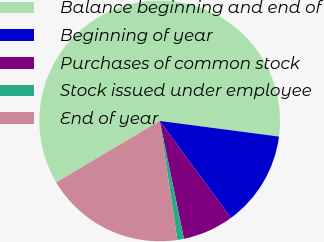<chart> <loc_0><loc_0><loc_500><loc_500><pie_chart><fcel>Balance beginning and end of<fcel>Beginning of year<fcel>Purchases of common stock<fcel>Stock issued under employee<fcel>End of year<nl><fcel>60.61%<fcel>12.83%<fcel>6.86%<fcel>0.89%<fcel>18.81%<nl></chart> 